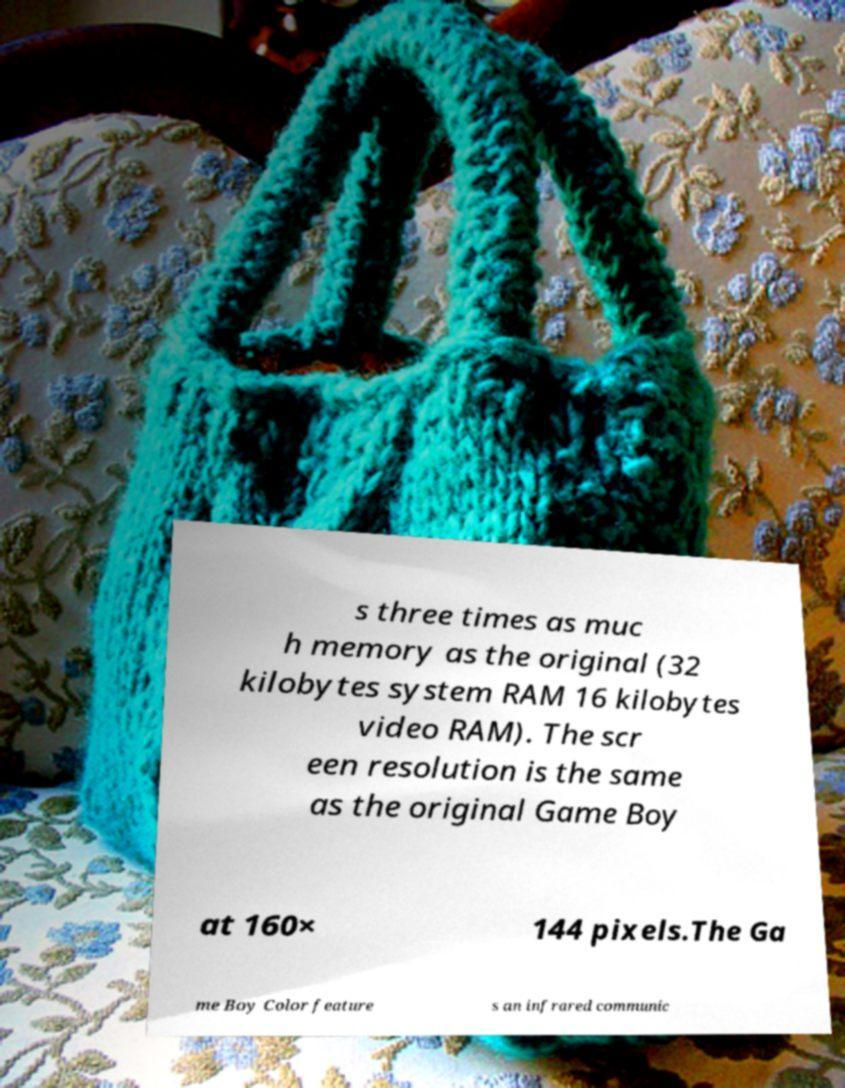Can you accurately transcribe the text from the provided image for me? s three times as muc h memory as the original (32 kilobytes system RAM 16 kilobytes video RAM). The scr een resolution is the same as the original Game Boy at 160× 144 pixels.The Ga me Boy Color feature s an infrared communic 